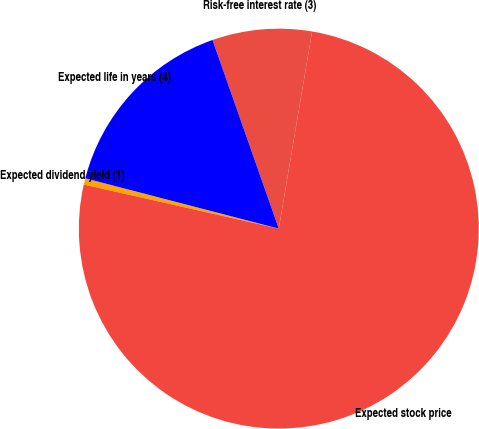Convert chart. <chart><loc_0><loc_0><loc_500><loc_500><pie_chart><fcel>Expected dividend yield (1)<fcel>Expected stock price<fcel>Risk-free interest rate (3)<fcel>Expected life in years (4)<nl><fcel>0.51%<fcel>75.87%<fcel>8.04%<fcel>15.57%<nl></chart> 